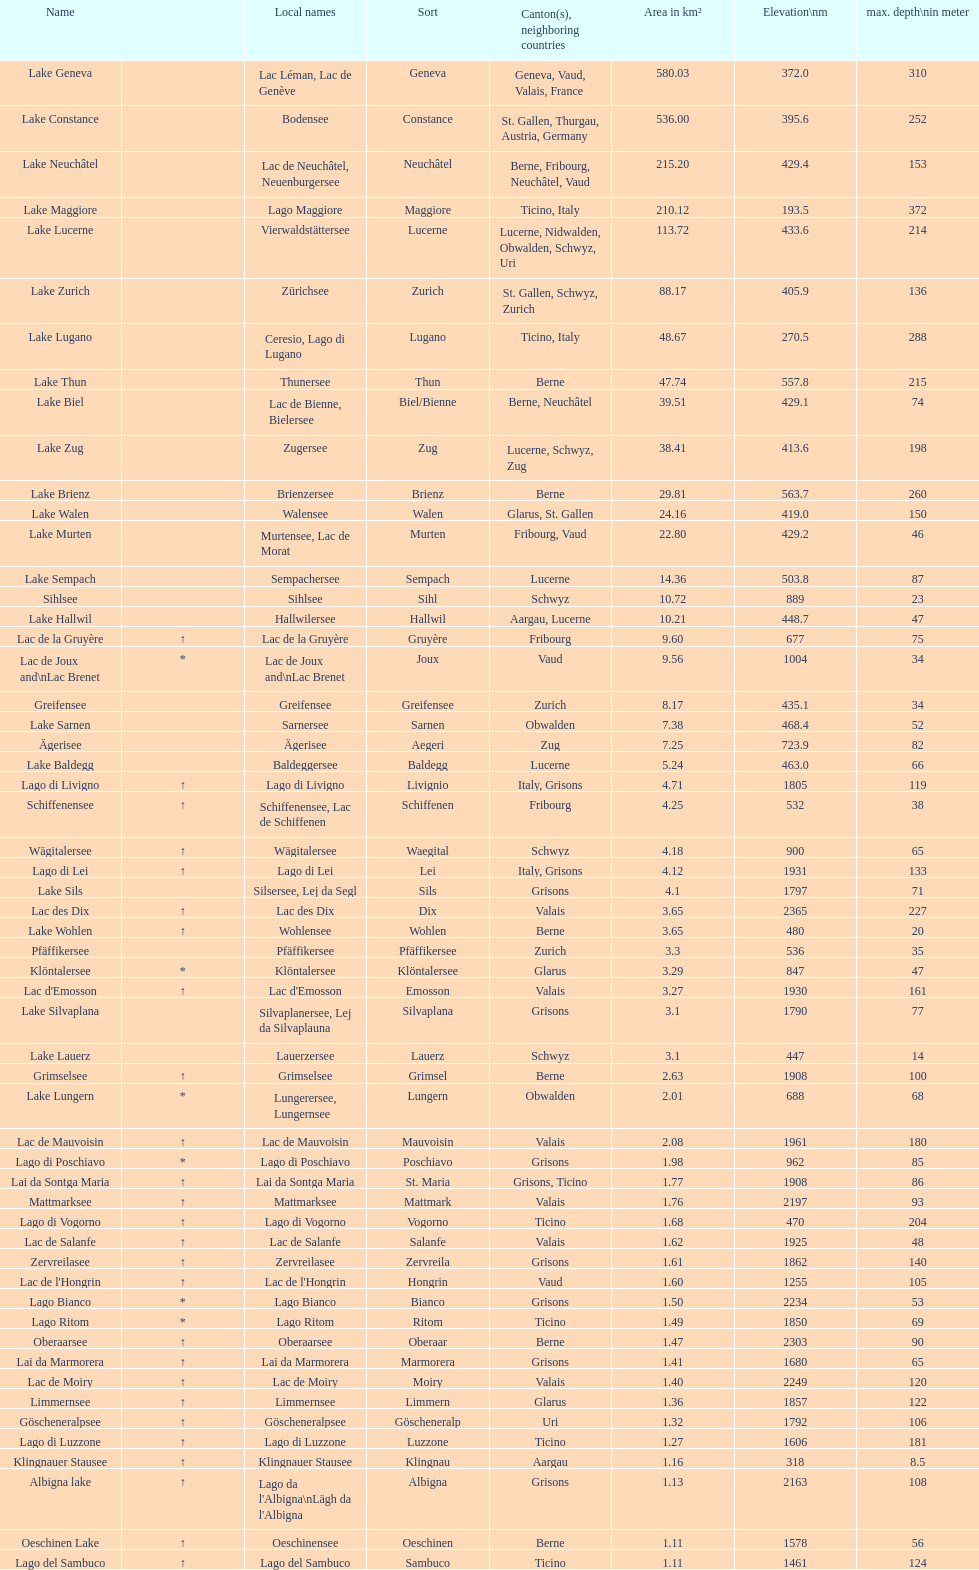Which lake holds the title for the greatest depth? Lake Maggiore. 